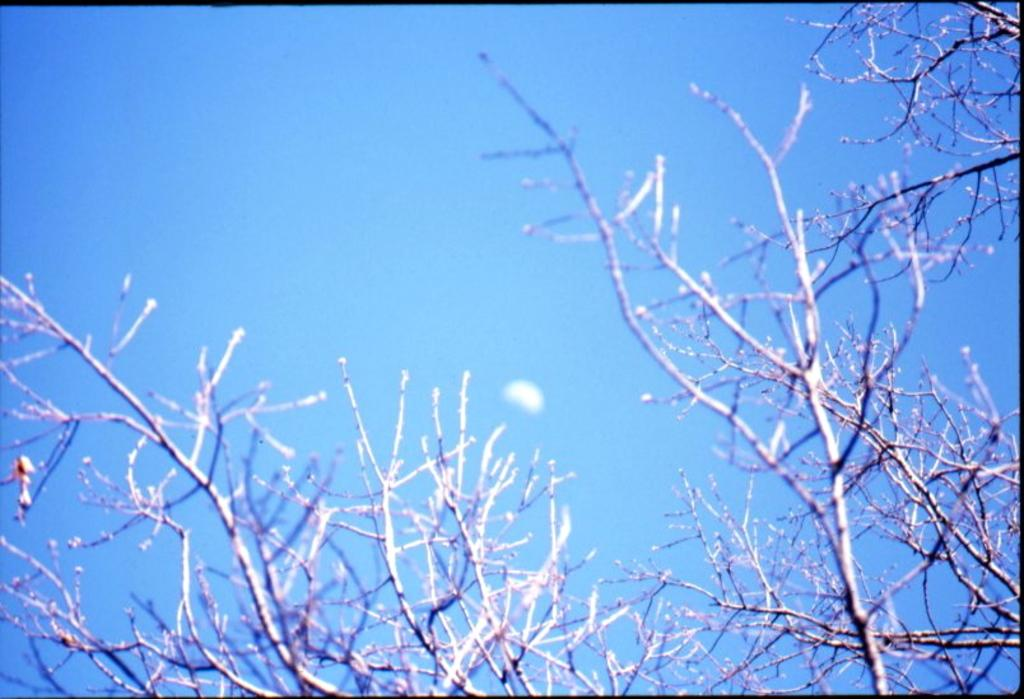What type of vegetation is visible in the image? There are branches of a tree in the image. What can be seen in the background of the image? The sky is visible in the background of the image. What type of ornament is hanging from the tree branches in the image? There is no ornament hanging from the tree branches in the image; only the branches are visible. 